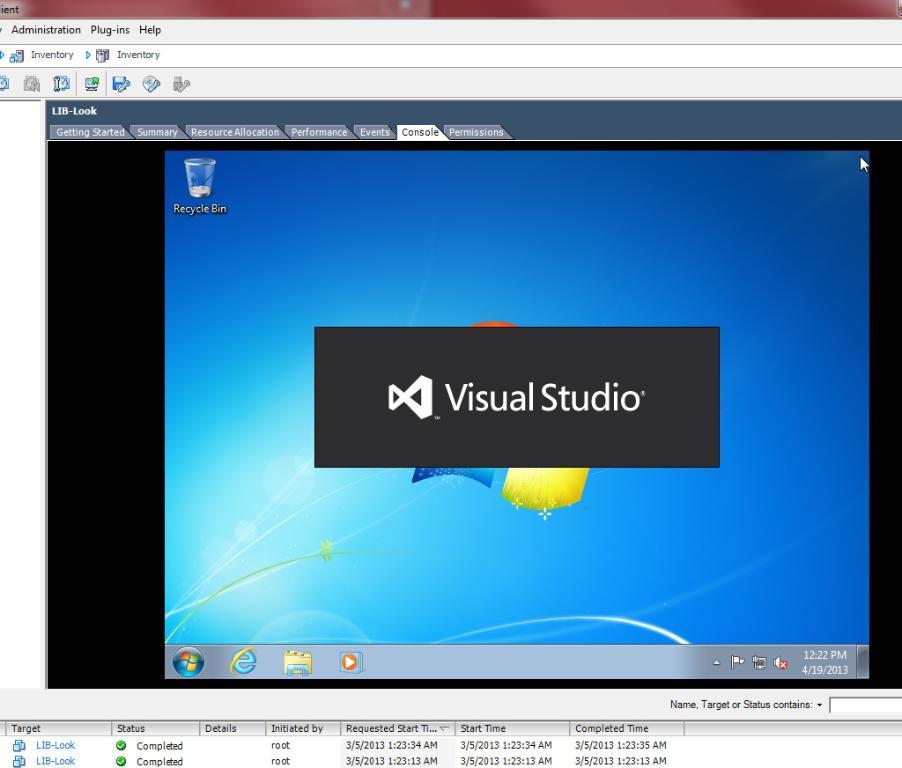What application is opening?
Your answer should be very brief. Visual studio. What tab is highlighted above the desktop?
Ensure brevity in your answer.  Console. 